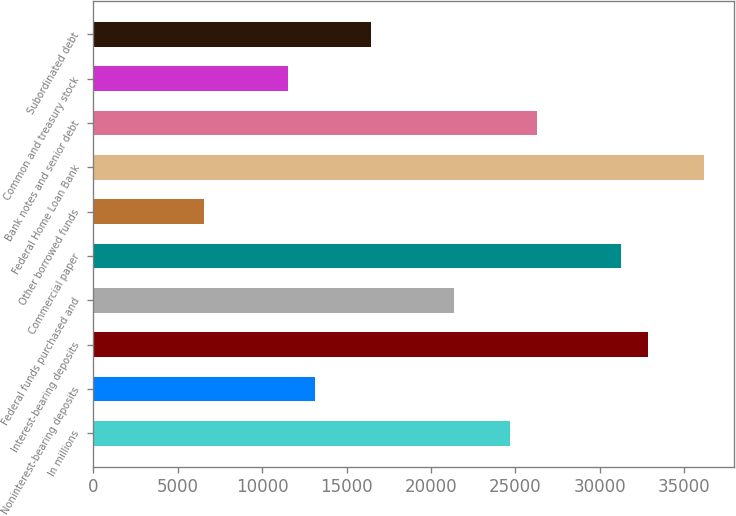Convert chart to OTSL. <chart><loc_0><loc_0><loc_500><loc_500><bar_chart><fcel>In millions<fcel>Noninterest-bearing deposits<fcel>Interest-bearing deposits<fcel>Federal funds purchased and<fcel>Commercial paper<fcel>Other borrowed funds<fcel>Federal Home Loan Bank<fcel>Bank notes and senior debt<fcel>Common and treasury stock<fcel>Subordinated debt<nl><fcel>24651<fcel>13148.6<fcel>32867<fcel>21364.6<fcel>31223.8<fcel>6575.8<fcel>36153.4<fcel>26294.2<fcel>11505.4<fcel>16435<nl></chart> 